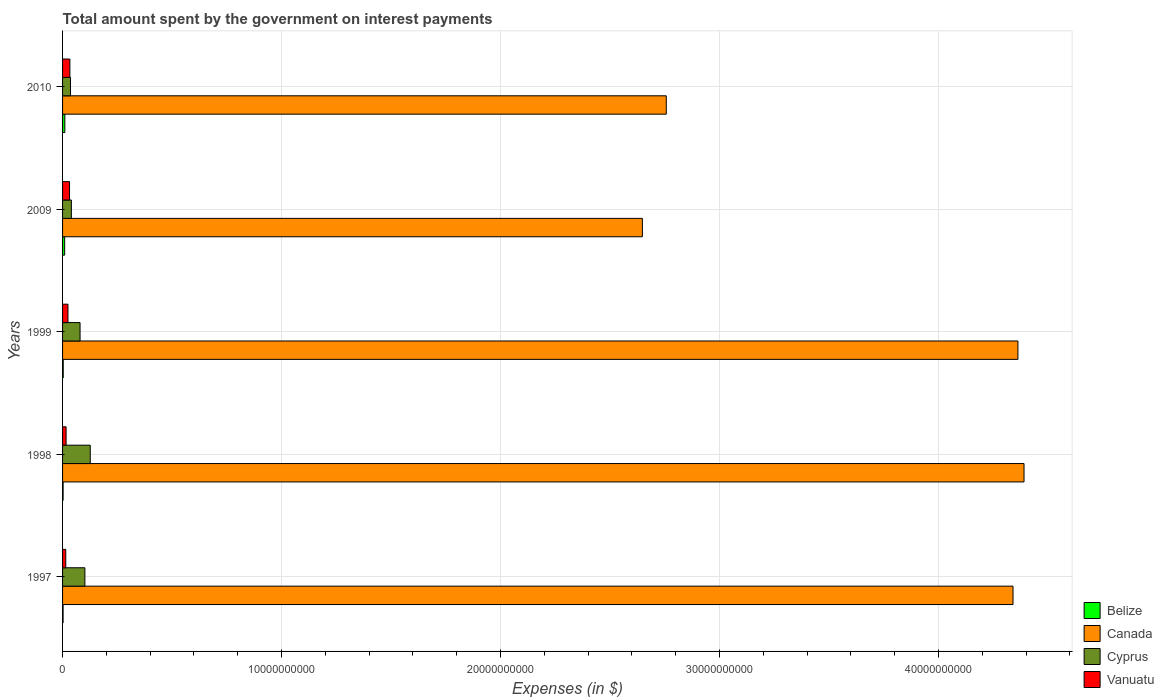How many different coloured bars are there?
Offer a terse response. 4. Are the number of bars on each tick of the Y-axis equal?
Offer a very short reply. Yes. In how many cases, is the number of bars for a given year not equal to the number of legend labels?
Your response must be concise. 0. What is the amount spent on interest payments by the government in Belize in 1999?
Provide a succinct answer. 3.02e+07. Across all years, what is the maximum amount spent on interest payments by the government in Canada?
Provide a short and direct response. 4.39e+1. Across all years, what is the minimum amount spent on interest payments by the government in Vanuatu?
Provide a succinct answer. 1.46e+08. In which year was the amount spent on interest payments by the government in Canada minimum?
Your response must be concise. 2009. What is the total amount spent on interest payments by the government in Belize in the graph?
Your answer should be very brief. 2.78e+08. What is the difference between the amount spent on interest payments by the government in Canada in 1997 and that in 2010?
Make the answer very short. 1.58e+1. What is the difference between the amount spent on interest payments by the government in Belize in 1998 and the amount spent on interest payments by the government in Canada in 1999?
Offer a very short reply. -4.36e+1. What is the average amount spent on interest payments by the government in Canada per year?
Offer a very short reply. 3.70e+1. In the year 2009, what is the difference between the amount spent on interest payments by the government in Cyprus and amount spent on interest payments by the government in Canada?
Offer a terse response. -2.61e+1. What is the ratio of the amount spent on interest payments by the government in Cyprus in 1998 to that in 2010?
Provide a short and direct response. 3.5. Is the amount spent on interest payments by the government in Belize in 1997 less than that in 2010?
Offer a terse response. Yes. What is the difference between the highest and the second highest amount spent on interest payments by the government in Canada?
Give a very brief answer. 2.78e+08. What is the difference between the highest and the lowest amount spent on interest payments by the government in Cyprus?
Give a very brief answer. 9.03e+08. In how many years, is the amount spent on interest payments by the government in Vanuatu greater than the average amount spent on interest payments by the government in Vanuatu taken over all years?
Your answer should be compact. 3. Is the sum of the amount spent on interest payments by the government in Cyprus in 1998 and 2010 greater than the maximum amount spent on interest payments by the government in Canada across all years?
Provide a succinct answer. No. What does the 2nd bar from the bottom in 1998 represents?
Your answer should be very brief. Canada. Is it the case that in every year, the sum of the amount spent on interest payments by the government in Cyprus and amount spent on interest payments by the government in Vanuatu is greater than the amount spent on interest payments by the government in Canada?
Give a very brief answer. No. How many bars are there?
Keep it short and to the point. 20. Are all the bars in the graph horizontal?
Ensure brevity in your answer.  Yes. What is the difference between two consecutive major ticks on the X-axis?
Your answer should be compact. 1.00e+1. Are the values on the major ticks of X-axis written in scientific E-notation?
Offer a terse response. No. Does the graph contain any zero values?
Give a very brief answer. No. What is the title of the graph?
Offer a very short reply. Total amount spent by the government on interest payments. What is the label or title of the X-axis?
Make the answer very short. Expenses (in $). What is the label or title of the Y-axis?
Your response must be concise. Years. What is the Expenses (in $) of Belize in 1997?
Your answer should be compact. 2.44e+07. What is the Expenses (in $) in Canada in 1997?
Make the answer very short. 4.34e+1. What is the Expenses (in $) of Cyprus in 1997?
Your answer should be very brief. 1.02e+09. What is the Expenses (in $) of Vanuatu in 1997?
Provide a succinct answer. 1.46e+08. What is the Expenses (in $) of Belize in 1998?
Keep it short and to the point. 2.46e+07. What is the Expenses (in $) in Canada in 1998?
Provide a short and direct response. 4.39e+1. What is the Expenses (in $) in Cyprus in 1998?
Ensure brevity in your answer.  1.26e+09. What is the Expenses (in $) in Vanuatu in 1998?
Provide a succinct answer. 1.61e+08. What is the Expenses (in $) in Belize in 1999?
Make the answer very short. 3.02e+07. What is the Expenses (in $) of Canada in 1999?
Your answer should be very brief. 4.36e+1. What is the Expenses (in $) in Cyprus in 1999?
Provide a succinct answer. 7.99e+08. What is the Expenses (in $) in Vanuatu in 1999?
Provide a succinct answer. 2.47e+08. What is the Expenses (in $) in Belize in 2009?
Provide a succinct answer. 9.58e+07. What is the Expenses (in $) of Canada in 2009?
Give a very brief answer. 2.65e+1. What is the Expenses (in $) in Cyprus in 2009?
Provide a succinct answer. 4.03e+08. What is the Expenses (in $) of Vanuatu in 2009?
Provide a short and direct response. 3.18e+08. What is the Expenses (in $) of Belize in 2010?
Provide a short and direct response. 1.03e+08. What is the Expenses (in $) in Canada in 2010?
Offer a very short reply. 2.76e+1. What is the Expenses (in $) of Cyprus in 2010?
Provide a short and direct response. 3.62e+08. What is the Expenses (in $) of Vanuatu in 2010?
Give a very brief answer. 3.34e+08. Across all years, what is the maximum Expenses (in $) in Belize?
Offer a terse response. 1.03e+08. Across all years, what is the maximum Expenses (in $) in Canada?
Keep it short and to the point. 4.39e+1. Across all years, what is the maximum Expenses (in $) in Cyprus?
Your answer should be compact. 1.26e+09. Across all years, what is the maximum Expenses (in $) in Vanuatu?
Your response must be concise. 3.34e+08. Across all years, what is the minimum Expenses (in $) of Belize?
Keep it short and to the point. 2.44e+07. Across all years, what is the minimum Expenses (in $) in Canada?
Your answer should be compact. 2.65e+1. Across all years, what is the minimum Expenses (in $) in Cyprus?
Keep it short and to the point. 3.62e+08. Across all years, what is the minimum Expenses (in $) of Vanuatu?
Offer a very short reply. 1.46e+08. What is the total Expenses (in $) of Belize in the graph?
Offer a terse response. 2.78e+08. What is the total Expenses (in $) of Canada in the graph?
Make the answer very short. 1.85e+11. What is the total Expenses (in $) in Cyprus in the graph?
Your answer should be very brief. 3.85e+09. What is the total Expenses (in $) in Vanuatu in the graph?
Offer a very short reply. 1.21e+09. What is the difference between the Expenses (in $) of Belize in 1997 and that in 1998?
Provide a succinct answer. -1.89e+05. What is the difference between the Expenses (in $) in Canada in 1997 and that in 1998?
Provide a succinct answer. -5.03e+08. What is the difference between the Expenses (in $) of Cyprus in 1997 and that in 1998?
Provide a succinct answer. -2.45e+08. What is the difference between the Expenses (in $) in Vanuatu in 1997 and that in 1998?
Give a very brief answer. -1.50e+07. What is the difference between the Expenses (in $) of Belize in 1997 and that in 1999?
Ensure brevity in your answer.  -5.80e+06. What is the difference between the Expenses (in $) of Canada in 1997 and that in 1999?
Your answer should be very brief. -2.25e+08. What is the difference between the Expenses (in $) in Cyprus in 1997 and that in 1999?
Ensure brevity in your answer.  2.20e+08. What is the difference between the Expenses (in $) of Vanuatu in 1997 and that in 1999?
Give a very brief answer. -1.01e+08. What is the difference between the Expenses (in $) of Belize in 1997 and that in 2009?
Your answer should be very brief. -7.14e+07. What is the difference between the Expenses (in $) of Canada in 1997 and that in 2009?
Your answer should be very brief. 1.69e+1. What is the difference between the Expenses (in $) of Cyprus in 1997 and that in 2009?
Make the answer very short. 6.17e+08. What is the difference between the Expenses (in $) in Vanuatu in 1997 and that in 2009?
Ensure brevity in your answer.  -1.72e+08. What is the difference between the Expenses (in $) in Belize in 1997 and that in 2010?
Offer a very short reply. -7.90e+07. What is the difference between the Expenses (in $) in Canada in 1997 and that in 2010?
Ensure brevity in your answer.  1.58e+1. What is the difference between the Expenses (in $) of Cyprus in 1997 and that in 2010?
Provide a short and direct response. 6.58e+08. What is the difference between the Expenses (in $) in Vanuatu in 1997 and that in 2010?
Make the answer very short. -1.88e+08. What is the difference between the Expenses (in $) of Belize in 1998 and that in 1999?
Your answer should be compact. -5.61e+06. What is the difference between the Expenses (in $) in Canada in 1998 and that in 1999?
Keep it short and to the point. 2.78e+08. What is the difference between the Expenses (in $) of Cyprus in 1998 and that in 1999?
Offer a terse response. 4.65e+08. What is the difference between the Expenses (in $) in Vanuatu in 1998 and that in 1999?
Your answer should be compact. -8.60e+07. What is the difference between the Expenses (in $) of Belize in 1998 and that in 2009?
Give a very brief answer. -7.12e+07. What is the difference between the Expenses (in $) in Canada in 1998 and that in 2009?
Your answer should be very brief. 1.74e+1. What is the difference between the Expenses (in $) in Cyprus in 1998 and that in 2009?
Provide a short and direct response. 8.61e+08. What is the difference between the Expenses (in $) in Vanuatu in 1998 and that in 2009?
Your answer should be compact. -1.57e+08. What is the difference between the Expenses (in $) in Belize in 1998 and that in 2010?
Provide a succinct answer. -7.88e+07. What is the difference between the Expenses (in $) of Canada in 1998 and that in 2010?
Offer a terse response. 1.63e+1. What is the difference between the Expenses (in $) in Cyprus in 1998 and that in 2010?
Offer a very short reply. 9.03e+08. What is the difference between the Expenses (in $) in Vanuatu in 1998 and that in 2010?
Offer a very short reply. -1.72e+08. What is the difference between the Expenses (in $) of Belize in 1999 and that in 2009?
Keep it short and to the point. -6.56e+07. What is the difference between the Expenses (in $) of Canada in 1999 and that in 2009?
Offer a terse response. 1.72e+1. What is the difference between the Expenses (in $) in Cyprus in 1999 and that in 2009?
Provide a short and direct response. 3.96e+08. What is the difference between the Expenses (in $) in Vanuatu in 1999 and that in 2009?
Offer a very short reply. -7.08e+07. What is the difference between the Expenses (in $) of Belize in 1999 and that in 2010?
Provide a succinct answer. -7.32e+07. What is the difference between the Expenses (in $) of Canada in 1999 and that in 2010?
Offer a terse response. 1.61e+1. What is the difference between the Expenses (in $) in Cyprus in 1999 and that in 2010?
Your answer should be compact. 4.37e+08. What is the difference between the Expenses (in $) in Vanuatu in 1999 and that in 2010?
Provide a succinct answer. -8.65e+07. What is the difference between the Expenses (in $) in Belize in 2009 and that in 2010?
Offer a terse response. -7.59e+06. What is the difference between the Expenses (in $) of Canada in 2009 and that in 2010?
Provide a short and direct response. -1.09e+09. What is the difference between the Expenses (in $) in Cyprus in 2009 and that in 2010?
Your answer should be compact. 4.11e+07. What is the difference between the Expenses (in $) of Vanuatu in 2009 and that in 2010?
Offer a terse response. -1.57e+07. What is the difference between the Expenses (in $) of Belize in 1997 and the Expenses (in $) of Canada in 1998?
Your response must be concise. -4.39e+1. What is the difference between the Expenses (in $) in Belize in 1997 and the Expenses (in $) in Cyprus in 1998?
Keep it short and to the point. -1.24e+09. What is the difference between the Expenses (in $) of Belize in 1997 and the Expenses (in $) of Vanuatu in 1998?
Offer a terse response. -1.37e+08. What is the difference between the Expenses (in $) in Canada in 1997 and the Expenses (in $) in Cyprus in 1998?
Keep it short and to the point. 4.21e+1. What is the difference between the Expenses (in $) of Canada in 1997 and the Expenses (in $) of Vanuatu in 1998?
Offer a very short reply. 4.32e+1. What is the difference between the Expenses (in $) in Cyprus in 1997 and the Expenses (in $) in Vanuatu in 1998?
Give a very brief answer. 8.58e+08. What is the difference between the Expenses (in $) in Belize in 1997 and the Expenses (in $) in Canada in 1999?
Your answer should be very brief. -4.36e+1. What is the difference between the Expenses (in $) of Belize in 1997 and the Expenses (in $) of Cyprus in 1999?
Your answer should be compact. -7.74e+08. What is the difference between the Expenses (in $) of Belize in 1997 and the Expenses (in $) of Vanuatu in 1999?
Your response must be concise. -2.23e+08. What is the difference between the Expenses (in $) in Canada in 1997 and the Expenses (in $) in Cyprus in 1999?
Give a very brief answer. 4.26e+1. What is the difference between the Expenses (in $) of Canada in 1997 and the Expenses (in $) of Vanuatu in 1999?
Offer a very short reply. 4.32e+1. What is the difference between the Expenses (in $) in Cyprus in 1997 and the Expenses (in $) in Vanuatu in 1999?
Provide a short and direct response. 7.72e+08. What is the difference between the Expenses (in $) in Belize in 1997 and the Expenses (in $) in Canada in 2009?
Your answer should be compact. -2.65e+1. What is the difference between the Expenses (in $) in Belize in 1997 and the Expenses (in $) in Cyprus in 2009?
Provide a succinct answer. -3.78e+08. What is the difference between the Expenses (in $) of Belize in 1997 and the Expenses (in $) of Vanuatu in 2009?
Your answer should be compact. -2.93e+08. What is the difference between the Expenses (in $) in Canada in 1997 and the Expenses (in $) in Cyprus in 2009?
Make the answer very short. 4.30e+1. What is the difference between the Expenses (in $) in Canada in 1997 and the Expenses (in $) in Vanuatu in 2009?
Provide a short and direct response. 4.31e+1. What is the difference between the Expenses (in $) of Cyprus in 1997 and the Expenses (in $) of Vanuatu in 2009?
Your answer should be compact. 7.01e+08. What is the difference between the Expenses (in $) of Belize in 1997 and the Expenses (in $) of Canada in 2010?
Give a very brief answer. -2.75e+1. What is the difference between the Expenses (in $) in Belize in 1997 and the Expenses (in $) in Cyprus in 2010?
Your response must be concise. -3.37e+08. What is the difference between the Expenses (in $) of Belize in 1997 and the Expenses (in $) of Vanuatu in 2010?
Your answer should be very brief. -3.09e+08. What is the difference between the Expenses (in $) in Canada in 1997 and the Expenses (in $) in Cyprus in 2010?
Offer a very short reply. 4.30e+1. What is the difference between the Expenses (in $) in Canada in 1997 and the Expenses (in $) in Vanuatu in 2010?
Provide a succinct answer. 4.31e+1. What is the difference between the Expenses (in $) in Cyprus in 1997 and the Expenses (in $) in Vanuatu in 2010?
Give a very brief answer. 6.86e+08. What is the difference between the Expenses (in $) of Belize in 1998 and the Expenses (in $) of Canada in 1999?
Offer a very short reply. -4.36e+1. What is the difference between the Expenses (in $) in Belize in 1998 and the Expenses (in $) in Cyprus in 1999?
Your answer should be very brief. -7.74e+08. What is the difference between the Expenses (in $) of Belize in 1998 and the Expenses (in $) of Vanuatu in 1999?
Your answer should be very brief. -2.22e+08. What is the difference between the Expenses (in $) in Canada in 1998 and the Expenses (in $) in Cyprus in 1999?
Make the answer very short. 4.31e+1. What is the difference between the Expenses (in $) in Canada in 1998 and the Expenses (in $) in Vanuatu in 1999?
Your answer should be compact. 4.37e+1. What is the difference between the Expenses (in $) in Cyprus in 1998 and the Expenses (in $) in Vanuatu in 1999?
Make the answer very short. 1.02e+09. What is the difference between the Expenses (in $) in Belize in 1998 and the Expenses (in $) in Canada in 2009?
Ensure brevity in your answer.  -2.65e+1. What is the difference between the Expenses (in $) of Belize in 1998 and the Expenses (in $) of Cyprus in 2009?
Ensure brevity in your answer.  -3.78e+08. What is the difference between the Expenses (in $) of Belize in 1998 and the Expenses (in $) of Vanuatu in 2009?
Your answer should be compact. -2.93e+08. What is the difference between the Expenses (in $) in Canada in 1998 and the Expenses (in $) in Cyprus in 2009?
Offer a very short reply. 4.35e+1. What is the difference between the Expenses (in $) of Canada in 1998 and the Expenses (in $) of Vanuatu in 2009?
Provide a short and direct response. 4.36e+1. What is the difference between the Expenses (in $) in Cyprus in 1998 and the Expenses (in $) in Vanuatu in 2009?
Offer a very short reply. 9.46e+08. What is the difference between the Expenses (in $) in Belize in 1998 and the Expenses (in $) in Canada in 2010?
Ensure brevity in your answer.  -2.75e+1. What is the difference between the Expenses (in $) in Belize in 1998 and the Expenses (in $) in Cyprus in 2010?
Provide a short and direct response. -3.37e+08. What is the difference between the Expenses (in $) in Belize in 1998 and the Expenses (in $) in Vanuatu in 2010?
Your response must be concise. -3.09e+08. What is the difference between the Expenses (in $) in Canada in 1998 and the Expenses (in $) in Cyprus in 2010?
Provide a short and direct response. 4.35e+1. What is the difference between the Expenses (in $) in Canada in 1998 and the Expenses (in $) in Vanuatu in 2010?
Offer a terse response. 4.36e+1. What is the difference between the Expenses (in $) in Cyprus in 1998 and the Expenses (in $) in Vanuatu in 2010?
Make the answer very short. 9.31e+08. What is the difference between the Expenses (in $) of Belize in 1999 and the Expenses (in $) of Canada in 2009?
Your answer should be very brief. -2.64e+1. What is the difference between the Expenses (in $) in Belize in 1999 and the Expenses (in $) in Cyprus in 2009?
Your answer should be compact. -3.72e+08. What is the difference between the Expenses (in $) of Belize in 1999 and the Expenses (in $) of Vanuatu in 2009?
Offer a terse response. -2.88e+08. What is the difference between the Expenses (in $) of Canada in 1999 and the Expenses (in $) of Cyprus in 2009?
Keep it short and to the point. 4.32e+1. What is the difference between the Expenses (in $) in Canada in 1999 and the Expenses (in $) in Vanuatu in 2009?
Offer a terse response. 4.33e+1. What is the difference between the Expenses (in $) in Cyprus in 1999 and the Expenses (in $) in Vanuatu in 2009?
Your answer should be compact. 4.81e+08. What is the difference between the Expenses (in $) in Belize in 1999 and the Expenses (in $) in Canada in 2010?
Your answer should be very brief. -2.75e+1. What is the difference between the Expenses (in $) in Belize in 1999 and the Expenses (in $) in Cyprus in 2010?
Your answer should be very brief. -3.31e+08. What is the difference between the Expenses (in $) of Belize in 1999 and the Expenses (in $) of Vanuatu in 2010?
Provide a succinct answer. -3.03e+08. What is the difference between the Expenses (in $) in Canada in 1999 and the Expenses (in $) in Cyprus in 2010?
Your answer should be very brief. 4.33e+1. What is the difference between the Expenses (in $) in Canada in 1999 and the Expenses (in $) in Vanuatu in 2010?
Provide a short and direct response. 4.33e+1. What is the difference between the Expenses (in $) in Cyprus in 1999 and the Expenses (in $) in Vanuatu in 2010?
Offer a very short reply. 4.65e+08. What is the difference between the Expenses (in $) of Belize in 2009 and the Expenses (in $) of Canada in 2010?
Your answer should be very brief. -2.75e+1. What is the difference between the Expenses (in $) of Belize in 2009 and the Expenses (in $) of Cyprus in 2010?
Provide a succinct answer. -2.66e+08. What is the difference between the Expenses (in $) of Belize in 2009 and the Expenses (in $) of Vanuatu in 2010?
Give a very brief answer. -2.38e+08. What is the difference between the Expenses (in $) of Canada in 2009 and the Expenses (in $) of Cyprus in 2010?
Your answer should be compact. 2.61e+1. What is the difference between the Expenses (in $) of Canada in 2009 and the Expenses (in $) of Vanuatu in 2010?
Ensure brevity in your answer.  2.61e+1. What is the difference between the Expenses (in $) of Cyprus in 2009 and the Expenses (in $) of Vanuatu in 2010?
Offer a very short reply. 6.91e+07. What is the average Expenses (in $) in Belize per year?
Your answer should be compact. 5.57e+07. What is the average Expenses (in $) of Canada per year?
Provide a succinct answer. 3.70e+1. What is the average Expenses (in $) of Cyprus per year?
Your response must be concise. 7.69e+08. What is the average Expenses (in $) in Vanuatu per year?
Give a very brief answer. 2.41e+08. In the year 1997, what is the difference between the Expenses (in $) of Belize and Expenses (in $) of Canada?
Ensure brevity in your answer.  -4.34e+1. In the year 1997, what is the difference between the Expenses (in $) of Belize and Expenses (in $) of Cyprus?
Keep it short and to the point. -9.95e+08. In the year 1997, what is the difference between the Expenses (in $) of Belize and Expenses (in $) of Vanuatu?
Your answer should be very brief. -1.22e+08. In the year 1997, what is the difference between the Expenses (in $) in Canada and Expenses (in $) in Cyprus?
Give a very brief answer. 4.24e+1. In the year 1997, what is the difference between the Expenses (in $) of Canada and Expenses (in $) of Vanuatu?
Provide a succinct answer. 4.33e+1. In the year 1997, what is the difference between the Expenses (in $) in Cyprus and Expenses (in $) in Vanuatu?
Provide a short and direct response. 8.73e+08. In the year 1998, what is the difference between the Expenses (in $) of Belize and Expenses (in $) of Canada?
Your answer should be compact. -4.39e+1. In the year 1998, what is the difference between the Expenses (in $) in Belize and Expenses (in $) in Cyprus?
Your answer should be compact. -1.24e+09. In the year 1998, what is the difference between the Expenses (in $) of Belize and Expenses (in $) of Vanuatu?
Offer a terse response. -1.36e+08. In the year 1998, what is the difference between the Expenses (in $) of Canada and Expenses (in $) of Cyprus?
Provide a short and direct response. 4.26e+1. In the year 1998, what is the difference between the Expenses (in $) of Canada and Expenses (in $) of Vanuatu?
Offer a terse response. 4.37e+1. In the year 1998, what is the difference between the Expenses (in $) in Cyprus and Expenses (in $) in Vanuatu?
Offer a terse response. 1.10e+09. In the year 1999, what is the difference between the Expenses (in $) of Belize and Expenses (in $) of Canada?
Your response must be concise. -4.36e+1. In the year 1999, what is the difference between the Expenses (in $) of Belize and Expenses (in $) of Cyprus?
Provide a short and direct response. -7.69e+08. In the year 1999, what is the difference between the Expenses (in $) of Belize and Expenses (in $) of Vanuatu?
Your answer should be compact. -2.17e+08. In the year 1999, what is the difference between the Expenses (in $) of Canada and Expenses (in $) of Cyprus?
Provide a succinct answer. 4.28e+1. In the year 1999, what is the difference between the Expenses (in $) in Canada and Expenses (in $) in Vanuatu?
Offer a terse response. 4.34e+1. In the year 1999, what is the difference between the Expenses (in $) in Cyprus and Expenses (in $) in Vanuatu?
Offer a very short reply. 5.52e+08. In the year 2009, what is the difference between the Expenses (in $) in Belize and Expenses (in $) in Canada?
Provide a short and direct response. -2.64e+1. In the year 2009, what is the difference between the Expenses (in $) of Belize and Expenses (in $) of Cyprus?
Provide a succinct answer. -3.07e+08. In the year 2009, what is the difference between the Expenses (in $) in Belize and Expenses (in $) in Vanuatu?
Give a very brief answer. -2.22e+08. In the year 2009, what is the difference between the Expenses (in $) of Canada and Expenses (in $) of Cyprus?
Ensure brevity in your answer.  2.61e+1. In the year 2009, what is the difference between the Expenses (in $) in Canada and Expenses (in $) in Vanuatu?
Keep it short and to the point. 2.62e+1. In the year 2009, what is the difference between the Expenses (in $) in Cyprus and Expenses (in $) in Vanuatu?
Provide a succinct answer. 8.48e+07. In the year 2010, what is the difference between the Expenses (in $) in Belize and Expenses (in $) in Canada?
Your answer should be very brief. -2.75e+1. In the year 2010, what is the difference between the Expenses (in $) of Belize and Expenses (in $) of Cyprus?
Your answer should be very brief. -2.58e+08. In the year 2010, what is the difference between the Expenses (in $) in Belize and Expenses (in $) in Vanuatu?
Your answer should be compact. -2.30e+08. In the year 2010, what is the difference between the Expenses (in $) in Canada and Expenses (in $) in Cyprus?
Make the answer very short. 2.72e+1. In the year 2010, what is the difference between the Expenses (in $) of Canada and Expenses (in $) of Vanuatu?
Ensure brevity in your answer.  2.72e+1. In the year 2010, what is the difference between the Expenses (in $) of Cyprus and Expenses (in $) of Vanuatu?
Ensure brevity in your answer.  2.80e+07. What is the ratio of the Expenses (in $) of Belize in 1997 to that in 1998?
Offer a terse response. 0.99. What is the ratio of the Expenses (in $) of Canada in 1997 to that in 1998?
Provide a succinct answer. 0.99. What is the ratio of the Expenses (in $) of Cyprus in 1997 to that in 1998?
Keep it short and to the point. 0.81. What is the ratio of the Expenses (in $) of Vanuatu in 1997 to that in 1998?
Your answer should be compact. 0.91. What is the ratio of the Expenses (in $) in Belize in 1997 to that in 1999?
Give a very brief answer. 0.81. What is the ratio of the Expenses (in $) of Canada in 1997 to that in 1999?
Ensure brevity in your answer.  0.99. What is the ratio of the Expenses (in $) in Cyprus in 1997 to that in 1999?
Make the answer very short. 1.28. What is the ratio of the Expenses (in $) in Vanuatu in 1997 to that in 1999?
Make the answer very short. 0.59. What is the ratio of the Expenses (in $) in Belize in 1997 to that in 2009?
Provide a short and direct response. 0.25. What is the ratio of the Expenses (in $) in Canada in 1997 to that in 2009?
Make the answer very short. 1.64. What is the ratio of the Expenses (in $) in Cyprus in 1997 to that in 2009?
Make the answer very short. 2.53. What is the ratio of the Expenses (in $) of Vanuatu in 1997 to that in 2009?
Make the answer very short. 0.46. What is the ratio of the Expenses (in $) of Belize in 1997 to that in 2010?
Your response must be concise. 0.24. What is the ratio of the Expenses (in $) in Canada in 1997 to that in 2010?
Provide a short and direct response. 1.57. What is the ratio of the Expenses (in $) in Cyprus in 1997 to that in 2010?
Your response must be concise. 2.82. What is the ratio of the Expenses (in $) in Vanuatu in 1997 to that in 2010?
Give a very brief answer. 0.44. What is the ratio of the Expenses (in $) of Belize in 1998 to that in 1999?
Your answer should be compact. 0.81. What is the ratio of the Expenses (in $) of Canada in 1998 to that in 1999?
Offer a terse response. 1.01. What is the ratio of the Expenses (in $) of Cyprus in 1998 to that in 1999?
Your response must be concise. 1.58. What is the ratio of the Expenses (in $) of Vanuatu in 1998 to that in 1999?
Ensure brevity in your answer.  0.65. What is the ratio of the Expenses (in $) in Belize in 1998 to that in 2009?
Your response must be concise. 0.26. What is the ratio of the Expenses (in $) in Canada in 1998 to that in 2009?
Make the answer very short. 1.66. What is the ratio of the Expenses (in $) in Cyprus in 1998 to that in 2009?
Your answer should be compact. 3.14. What is the ratio of the Expenses (in $) in Vanuatu in 1998 to that in 2009?
Provide a short and direct response. 0.51. What is the ratio of the Expenses (in $) of Belize in 1998 to that in 2010?
Ensure brevity in your answer.  0.24. What is the ratio of the Expenses (in $) of Canada in 1998 to that in 2010?
Make the answer very short. 1.59. What is the ratio of the Expenses (in $) of Cyprus in 1998 to that in 2010?
Your answer should be very brief. 3.5. What is the ratio of the Expenses (in $) of Vanuatu in 1998 to that in 2010?
Provide a short and direct response. 0.48. What is the ratio of the Expenses (in $) in Belize in 1999 to that in 2009?
Your response must be concise. 0.32. What is the ratio of the Expenses (in $) of Canada in 1999 to that in 2009?
Give a very brief answer. 1.65. What is the ratio of the Expenses (in $) of Cyprus in 1999 to that in 2009?
Provide a short and direct response. 1.98. What is the ratio of the Expenses (in $) of Vanuatu in 1999 to that in 2009?
Your answer should be very brief. 0.78. What is the ratio of the Expenses (in $) of Belize in 1999 to that in 2010?
Give a very brief answer. 0.29. What is the ratio of the Expenses (in $) in Canada in 1999 to that in 2010?
Provide a succinct answer. 1.58. What is the ratio of the Expenses (in $) of Cyprus in 1999 to that in 2010?
Keep it short and to the point. 2.21. What is the ratio of the Expenses (in $) in Vanuatu in 1999 to that in 2010?
Provide a succinct answer. 0.74. What is the ratio of the Expenses (in $) in Belize in 2009 to that in 2010?
Provide a short and direct response. 0.93. What is the ratio of the Expenses (in $) in Canada in 2009 to that in 2010?
Your answer should be very brief. 0.96. What is the ratio of the Expenses (in $) in Cyprus in 2009 to that in 2010?
Keep it short and to the point. 1.11. What is the ratio of the Expenses (in $) of Vanuatu in 2009 to that in 2010?
Offer a very short reply. 0.95. What is the difference between the highest and the second highest Expenses (in $) of Belize?
Make the answer very short. 7.59e+06. What is the difference between the highest and the second highest Expenses (in $) in Canada?
Provide a short and direct response. 2.78e+08. What is the difference between the highest and the second highest Expenses (in $) in Cyprus?
Your answer should be very brief. 2.45e+08. What is the difference between the highest and the second highest Expenses (in $) of Vanuatu?
Provide a short and direct response. 1.57e+07. What is the difference between the highest and the lowest Expenses (in $) in Belize?
Your answer should be very brief. 7.90e+07. What is the difference between the highest and the lowest Expenses (in $) of Canada?
Your response must be concise. 1.74e+1. What is the difference between the highest and the lowest Expenses (in $) of Cyprus?
Provide a short and direct response. 9.03e+08. What is the difference between the highest and the lowest Expenses (in $) in Vanuatu?
Make the answer very short. 1.88e+08. 